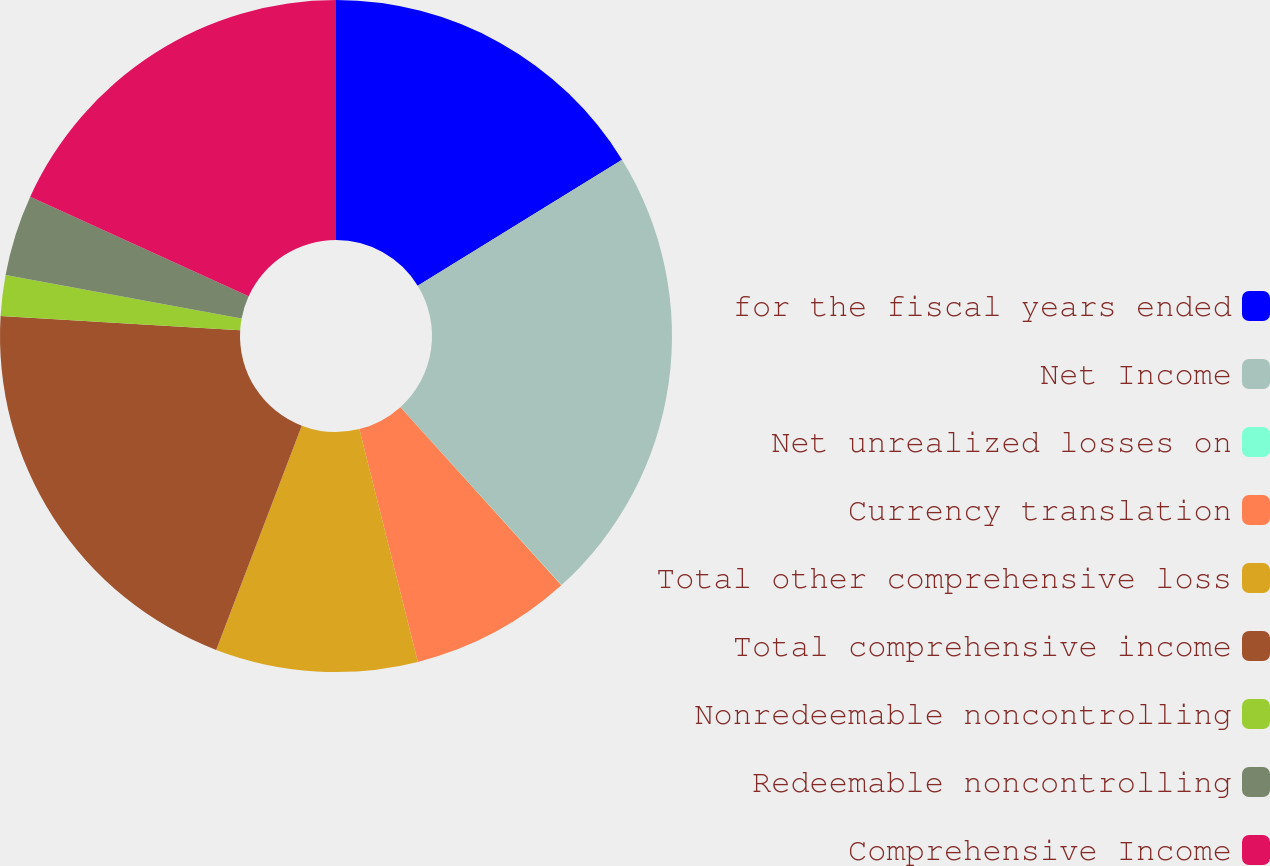Convert chart. <chart><loc_0><loc_0><loc_500><loc_500><pie_chart><fcel>for the fiscal years ended<fcel>Net Income<fcel>Net unrealized losses on<fcel>Currency translation<fcel>Total other comprehensive loss<fcel>Total comprehensive income<fcel>Nonredeemable noncontrolling<fcel>Redeemable noncontrolling<fcel>Comprehensive Income<nl><fcel>16.21%<fcel>22.08%<fcel>0.02%<fcel>7.78%<fcel>9.72%<fcel>20.14%<fcel>1.96%<fcel>3.9%<fcel>18.2%<nl></chart> 